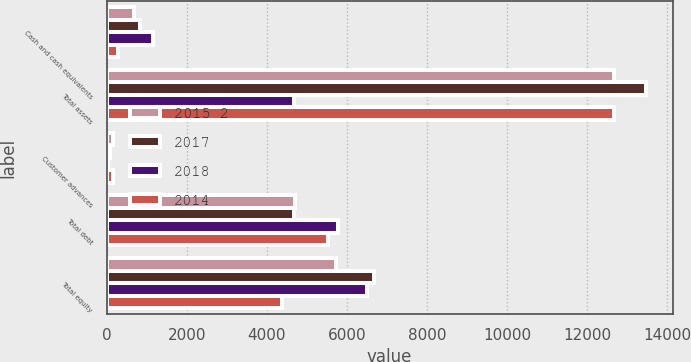Convert chart. <chart><loc_0><loc_0><loc_500><loc_500><stacked_bar_chart><ecel><fcel>Cash and cash equivalents<fcel>Total assets<fcel>Customer advances<fcel>Total debt<fcel>Total equity<nl><fcel>2015 2<fcel>682<fcel>12661<fcel>149<fcel>4698<fcel>5731<nl><fcel>2017<fcel>835<fcel>13463<fcel>89<fcel>4692<fcel>6684<nl><fcel>2018<fcel>1164<fcel>4692<fcel>42<fcel>5778<fcel>6492<nl><fcel>2014<fcel>286<fcel>12683<fcel>162<fcel>5537<fcel>4387<nl></chart> 